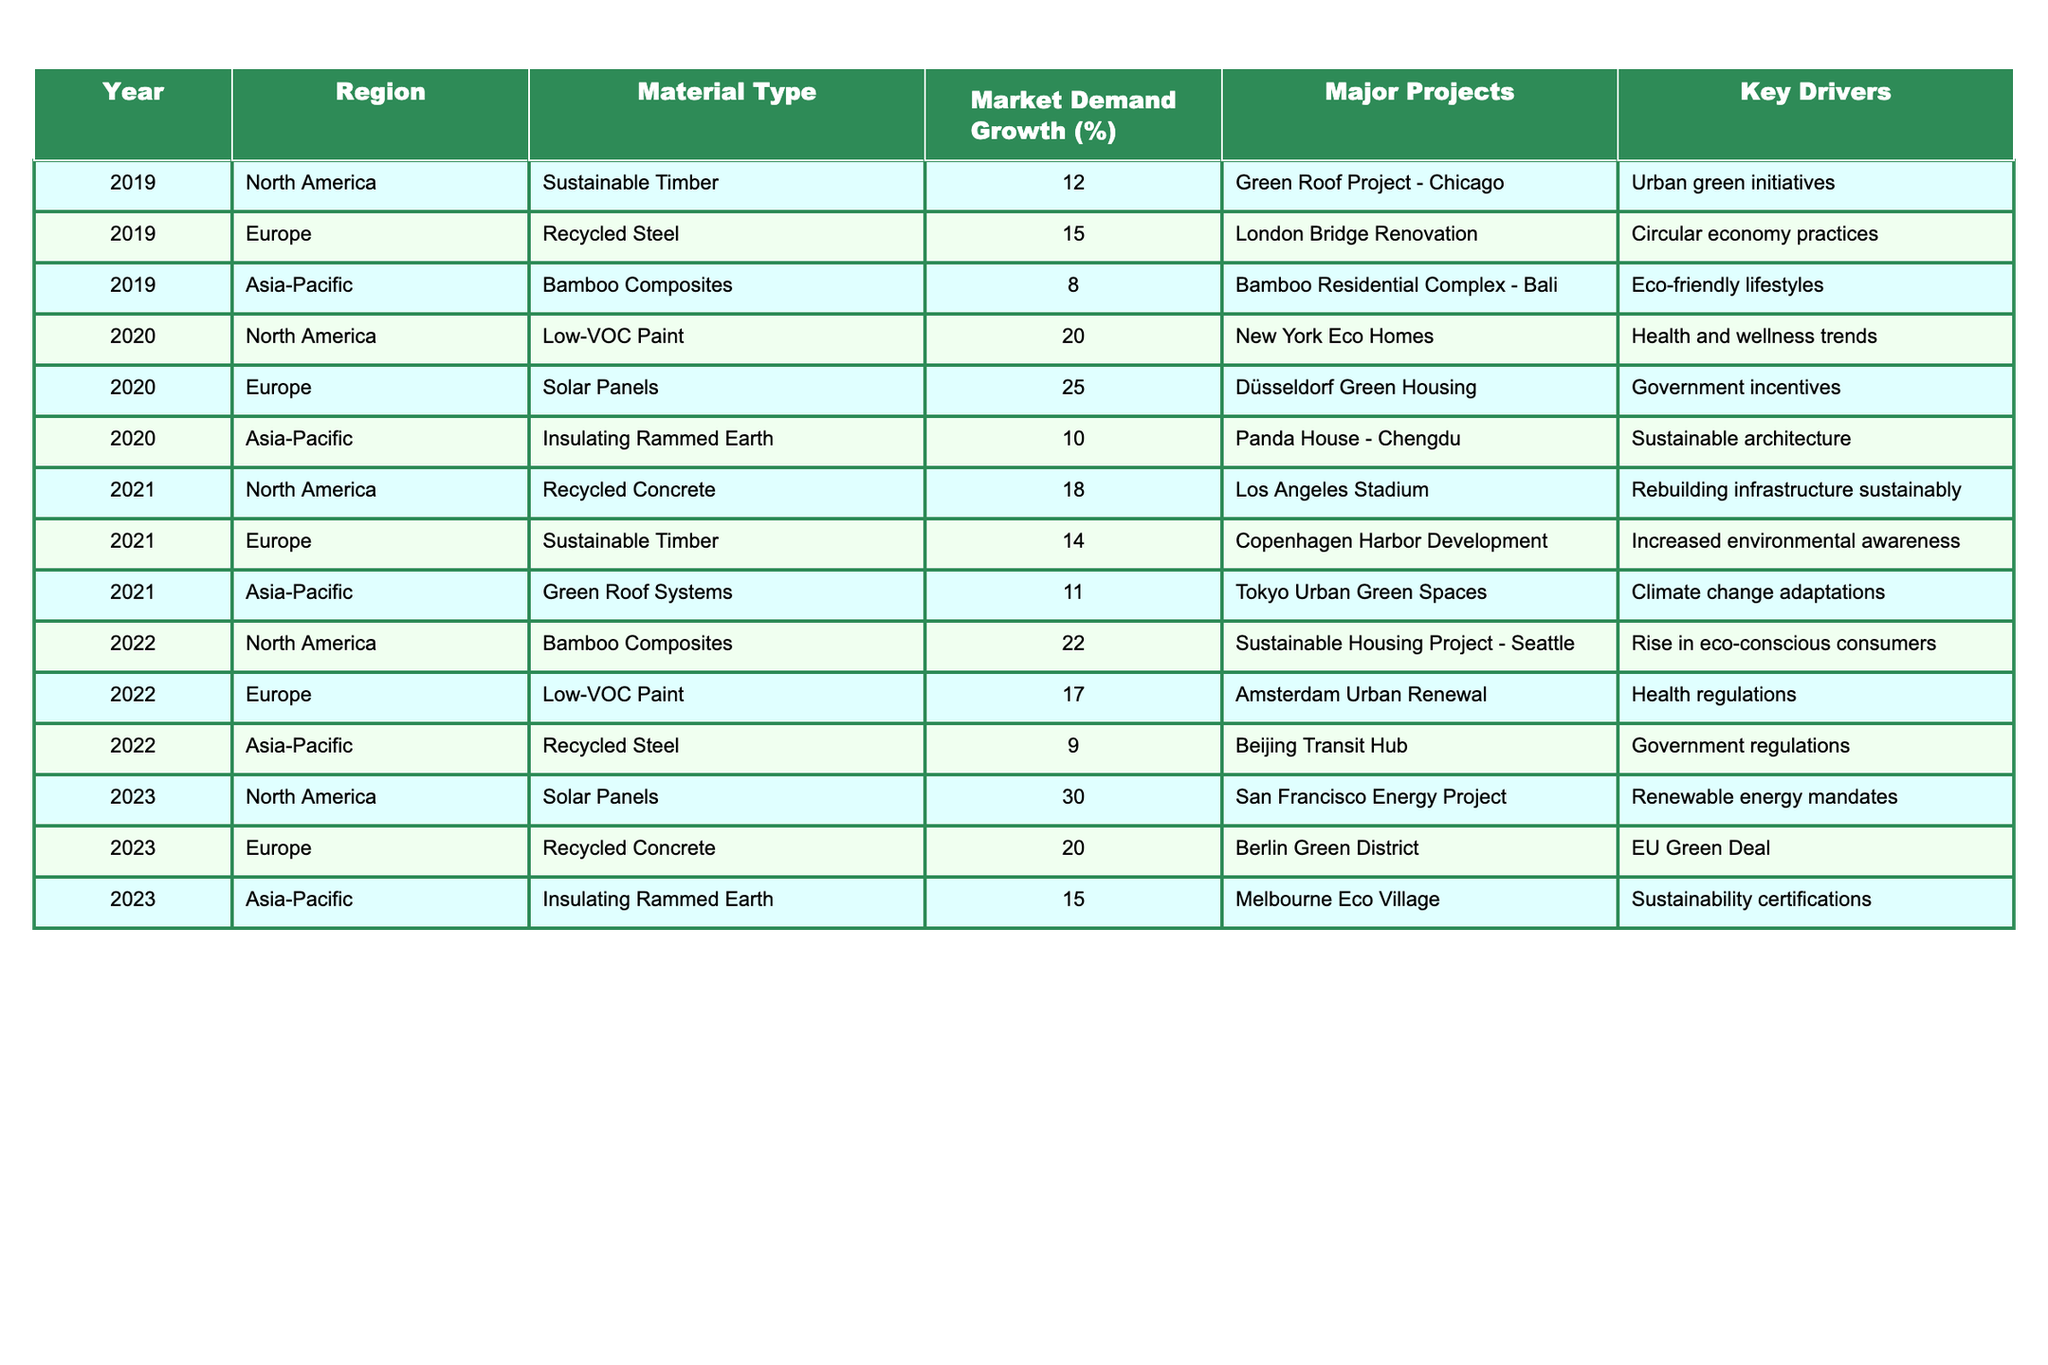What was the market demand growth percentage for Low-VOC Paint in North America in 2020? The table shows that the market demand growth percentage for Low-VOC Paint in North America in 2020 is 20%.
Answer: 20% Which material type had the highest market demand growth in Europe in 2020? According to the table, Solar Panels had the highest market demand growth in Europe in 2020, with a percentage of 25%.
Answer: Solar Panels In which year did Bamboo Composites experience the highest market demand growth in North America? The table indicates that Bamboo Composites had a market demand growth of 22% in North America in 2022, which is the highest for that material type over the years listed.
Answer: 2022 What percentage of market demand growth did Recycled Steel have in Asia-Pacific in 2022? According to the table, Recycled Steel had a market demand growth of 9% in Asia-Pacific in 2022.
Answer: 9% Was the market demand growth for Sustainable Timber in Europe in 2021 higher or lower than in 2019? In 2021, the market demand growth for Sustainable Timber in Europe was 14%, compared to 15% in 2019. Therefore, it was lower in 2021.
Answer: Lower What is the overall average market demand growth percentage for Solar Panels across the years provided? The table shows Solar Panels had growth percentages of 25% in 2020 and 30% in 2023. The average is (25 + 30) / 2 = 27.5%.
Answer: 27.5% Which region saw the highest market demand growth for eco-friendly construction materials in 2023? In 2023, North America saw the highest market demand growth for Solar Panels at 30%, compared to other regions and materials listed.
Answer: North America Calculate the total market demand growth percentage for all types of materials in Asia-Pacific for the year 2022. The table shows the percentages for Asia-Pacific in 2022 as 9% (Recycled Steel), 15% (Insulating Rammed Earth), and 22% (Bamboo Composites). Adding them gives 9 + 15 + 22 = 46%.
Answer: 46% What key driver supported the market demand growth for Solar Panels in 2020? The table notes that government incentives were the key driver for the market demand growth of Solar Panels in 2020.
Answer: Government incentives Was there any year where Insulating Rammed Earth had a market demand growth of more than 15%? From the table, Insulating Rammed Earth had a growth of 10% in 2020 and 15% in 2023, so the answer is no, as neither exceeds 15%.
Answer: No How many major projects were associated with Recycled Concrete across all years mentioned? The table lists one major project associated with Recycled Concrete in 2021 (Los Angeles Stadium) and one in 2023 (Berlin Green District), totaling two projects.
Answer: 2 